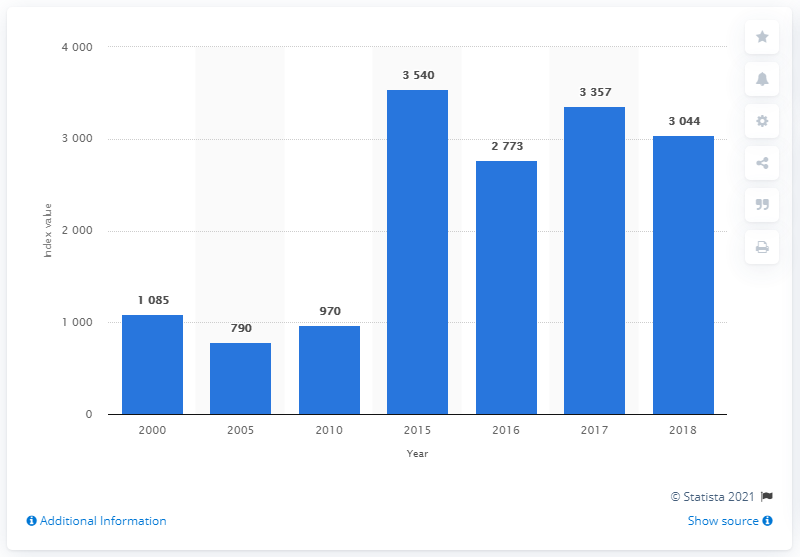Highlight a few significant elements in this photo. The median value of the index is 2773. The peak of the index was reached in 2014. 